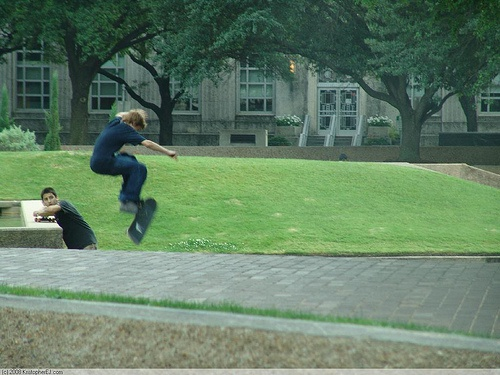Describe the objects in this image and their specific colors. I can see people in darkgreen, black, blue, darkblue, and gray tones, people in darkgreen, black, gray, green, and olive tones, skateboard in darkgreen, teal, and black tones, potted plant in darkgreen, teal, and darkgray tones, and potted plant in darkgreen, teal, and darkgray tones in this image. 